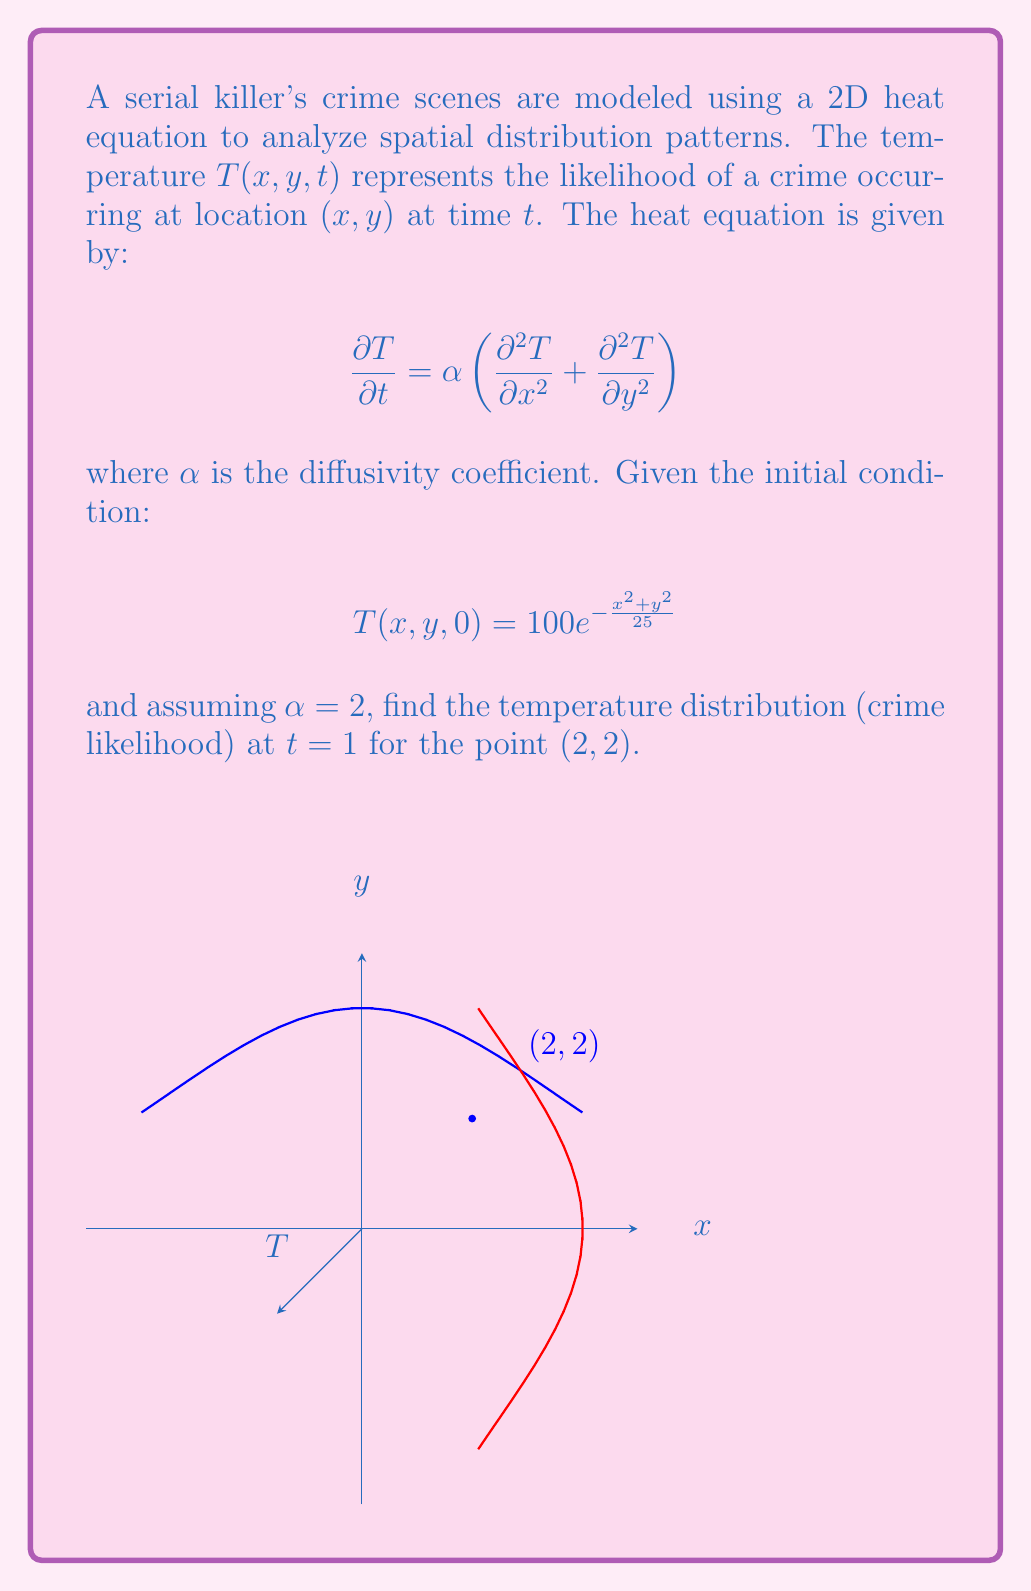Solve this math problem. To solve this problem, we'll use the solution to the 2D heat equation with an initial Gaussian distribution:

1) The general solution for the 2D heat equation with initial condition $T(x,y,0) = T_0e^{-\frac{x^2+y^2}{2\sigma^2}}$ is:

   $$T(x,y,t) = \frac{T_0\sigma^2}{\sigma^2 + 2\alpha t}e^{-\frac{x^2+y^2}{2(\sigma^2 + 2\alpha t)}}$$

2) In our case, $T_0 = 100$, $\sigma^2 = 25/2$, and $\alpha = 2$. Substituting these values:

   $$T(x,y,t) = \frac{100 \cdot (25/2)}{(25/2) + 2 \cdot 2t}e^{-\frac{x^2+y^2}{2((25/2) + 2 \cdot 2t)}}$$

3) Simplify:
   
   $$T(x,y,t) = \frac{1250}{25 + 8t}e^{-\frac{x^2+y^2}{25 + 8t}}$$

4) Now, we need to find $T(2,2,1)$. Substituting $x=2$, $y=2$, and $t=1$:

   $$T(2,2,1) = \frac{1250}{25 + 8(1)}e^{-\frac{2^2+2^2}{25 + 8(1)}}$$

5) Simplify:

   $$T(2,2,1) = \frac{1250}{33}e^{-\frac{8}{33}} \approx 35.86$$
Answer: 35.86 